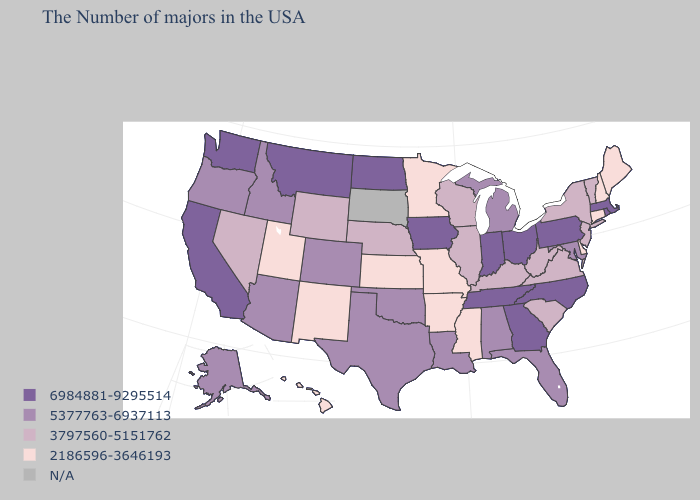Does South Carolina have the highest value in the USA?
Write a very short answer. No. What is the highest value in states that border Louisiana?
Concise answer only. 5377763-6937113. Name the states that have a value in the range 2186596-3646193?
Give a very brief answer. Maine, New Hampshire, Connecticut, Delaware, Mississippi, Missouri, Arkansas, Minnesota, Kansas, New Mexico, Utah, Hawaii. What is the value of North Carolina?
Write a very short answer. 6984881-9295514. What is the value of Ohio?
Short answer required. 6984881-9295514. What is the value of Connecticut?
Be succinct. 2186596-3646193. Which states have the highest value in the USA?
Quick response, please. Massachusetts, Rhode Island, Pennsylvania, North Carolina, Ohio, Georgia, Indiana, Tennessee, Iowa, North Dakota, Montana, California, Washington. Among the states that border Nevada , which have the lowest value?
Concise answer only. Utah. Among the states that border Minnesota , which have the lowest value?
Quick response, please. Wisconsin. Does the first symbol in the legend represent the smallest category?
Concise answer only. No. What is the lowest value in the USA?
Concise answer only. 2186596-3646193. Does the first symbol in the legend represent the smallest category?
Give a very brief answer. No. Name the states that have a value in the range 6984881-9295514?
Quick response, please. Massachusetts, Rhode Island, Pennsylvania, North Carolina, Ohio, Georgia, Indiana, Tennessee, Iowa, North Dakota, Montana, California, Washington. Does Mississippi have the lowest value in the USA?
Give a very brief answer. Yes. 